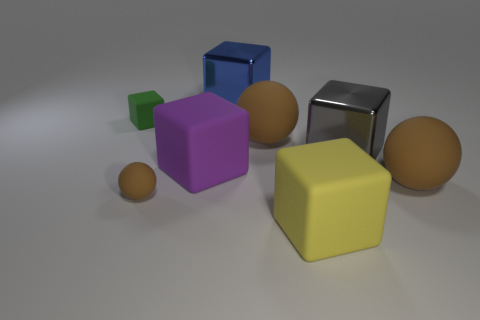What material is the big yellow object that is the same shape as the gray shiny object?
Your answer should be compact. Rubber. How many rubber objects are yellow objects or small green things?
Provide a short and direct response. 2. What is the shape of the gray metallic object?
Offer a very short reply. Cube. Is there any other thing that is made of the same material as the tiny ball?
Provide a short and direct response. Yes. Is the material of the small cube the same as the big yellow object?
Offer a very short reply. Yes. Is there a large matte sphere left of the large matte cube that is in front of the small object right of the green matte object?
Ensure brevity in your answer.  Yes. What number of other objects are the same shape as the big purple rubber thing?
Give a very brief answer. 4. There is a brown object that is both in front of the large gray shiny block and behind the small brown ball; what is its shape?
Give a very brief answer. Sphere. What is the color of the metal thing that is in front of the rubber cube to the left of the purple cube to the left of the gray cube?
Keep it short and to the point. Gray. Is the number of big brown objects that are behind the gray metallic block greater than the number of large yellow rubber objects behind the large purple object?
Give a very brief answer. Yes. 